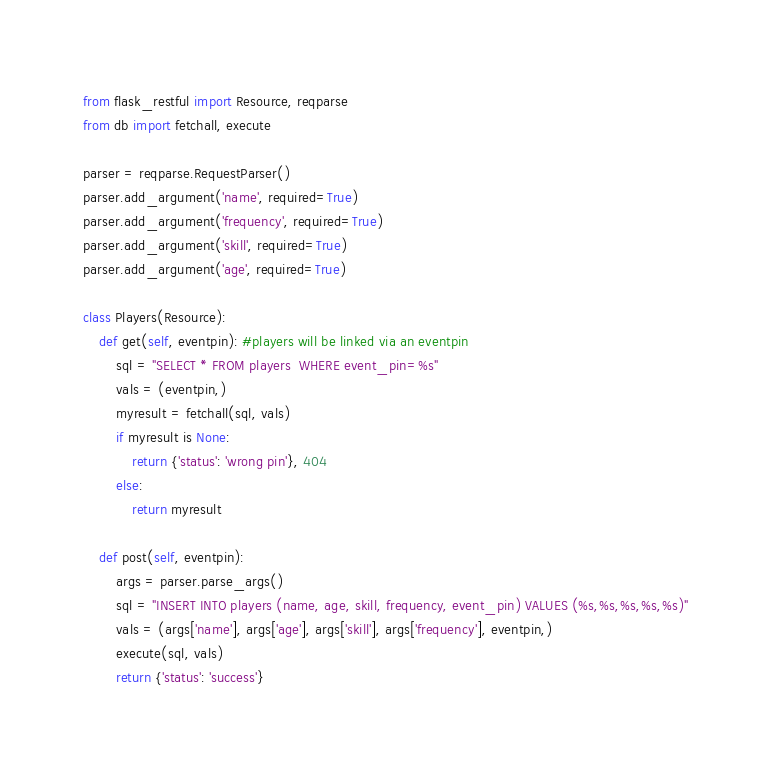<code> <loc_0><loc_0><loc_500><loc_500><_Python_>from flask_restful import Resource, reqparse
from db import fetchall, execute

parser = reqparse.RequestParser()
parser.add_argument('name', required=True)
parser.add_argument('frequency', required=True)
parser.add_argument('skill', required=True)
parser.add_argument('age', required=True)

class Players(Resource):
    def get(self, eventpin): #players will be linked via an eventpin
        sql = "SELECT * FROM players  WHERE event_pin=%s"
        vals = (eventpin,)
        myresult = fetchall(sql, vals)
        if myresult is None:
            return {'status': 'wrong pin'}, 404
        else:
            return myresult

    def post(self, eventpin):
        args = parser.parse_args()
        sql = "INSERT INTO players (name, age, skill, frequency, event_pin) VALUES (%s,%s,%s,%s,%s)"
        vals = (args['name'], args['age'], args['skill'], args['frequency'], eventpin,)
        execute(sql, vals)
        return {'status': 'success'}
</code> 